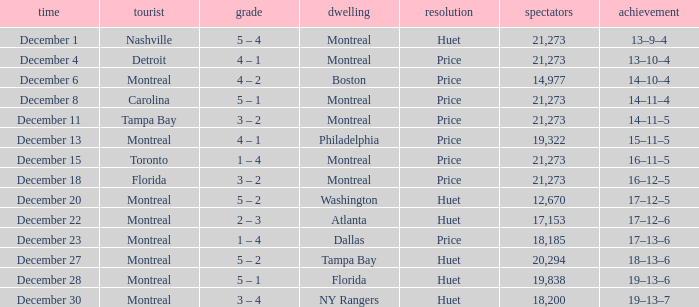What is the record on December 4? 13–10–4. 